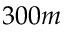<formula> <loc_0><loc_0><loc_500><loc_500>3 0 0 m</formula> 